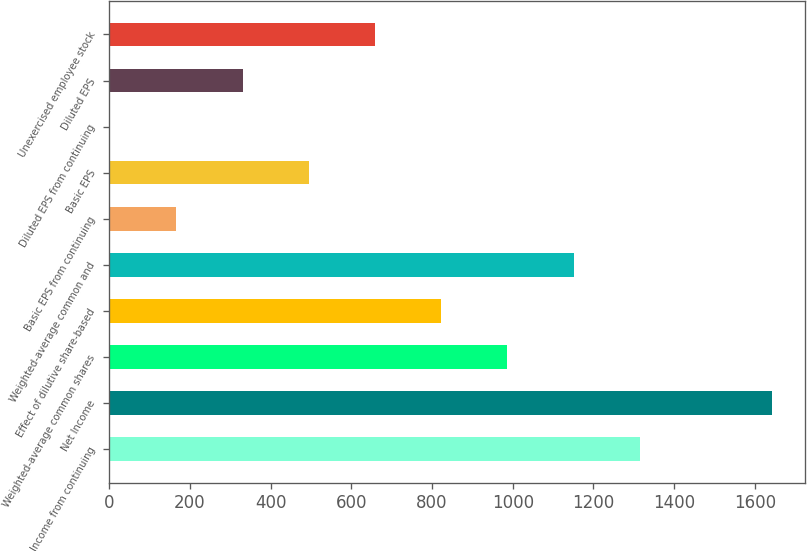<chart> <loc_0><loc_0><loc_500><loc_500><bar_chart><fcel>Income from continuing<fcel>Net Income<fcel>Weighted-average common shares<fcel>Effect of dilutive share-based<fcel>Weighted-average common and<fcel>Basic EPS from continuing<fcel>Basic EPS<fcel>Diluted EPS from continuing<fcel>Diluted EPS<fcel>Unexercised employee stock<nl><fcel>1314.94<fcel>1643<fcel>986.84<fcel>822.79<fcel>1150.89<fcel>166.59<fcel>494.69<fcel>2.54<fcel>330.64<fcel>658.74<nl></chart> 